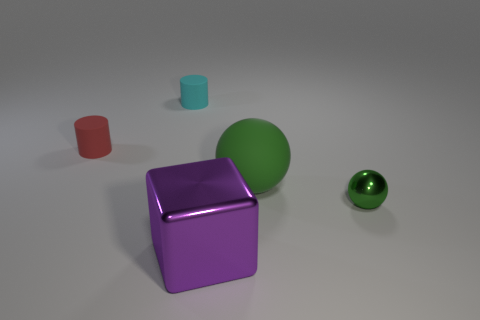There is a green thing that is on the right side of the large green thing; what size is it?
Offer a terse response. Small. The other cylinder that is the same material as the red cylinder is what size?
Keep it short and to the point. Small. What number of other spheres have the same color as the rubber ball?
Your response must be concise. 1. Are any small red matte cylinders visible?
Keep it short and to the point. Yes. Is the shape of the cyan matte thing the same as the rubber thing left of the cyan matte cylinder?
Keep it short and to the point. Yes. The metal thing left of the metallic object on the right side of the metal thing to the left of the tiny green object is what color?
Provide a short and direct response. Purple. Are there any big green matte objects in front of the shiny ball?
Keep it short and to the point. No. What is the size of the thing that is the same color as the rubber sphere?
Make the answer very short. Small. Is there another object made of the same material as the cyan thing?
Your answer should be very brief. Yes. The large metallic thing has what color?
Make the answer very short. Purple. 